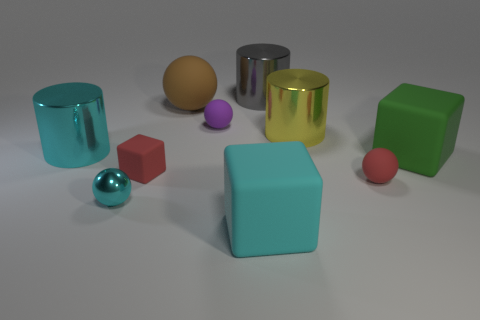Subtract all cyan metallic cylinders. How many cylinders are left? 2 Subtract all spheres. How many objects are left? 6 Subtract all yellow cylinders. How many cylinders are left? 2 Subtract 4 spheres. How many spheres are left? 0 Subtract all purple cylinders. Subtract all gray spheres. How many cylinders are left? 3 Subtract all brown spheres. How many cyan cylinders are left? 1 Subtract all brown rubber objects. Subtract all large cyan things. How many objects are left? 7 Add 9 cyan metal cylinders. How many cyan metal cylinders are left? 10 Add 7 tiny red rubber cubes. How many tiny red rubber cubes exist? 8 Subtract 1 red cubes. How many objects are left? 9 